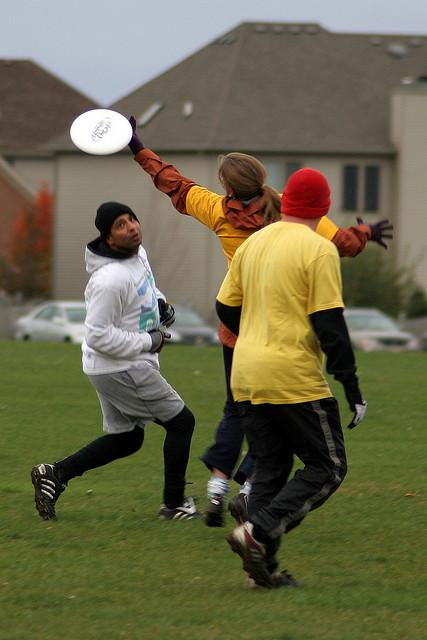What sport is being played? frisbee 